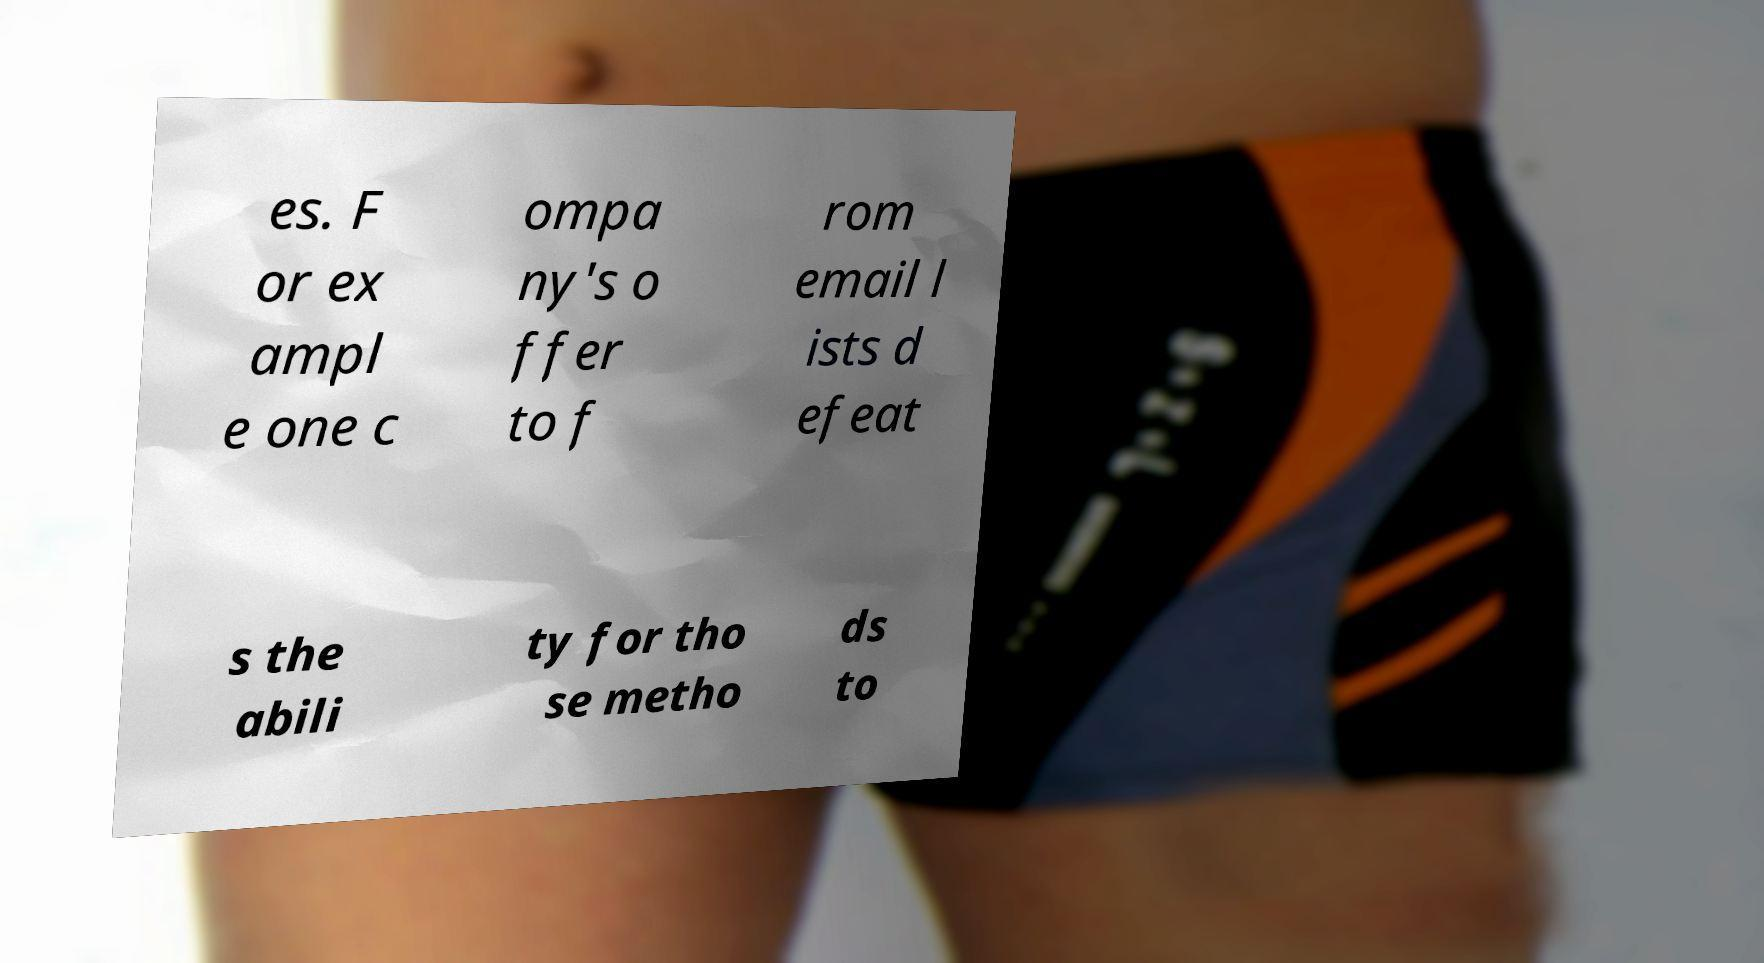For documentation purposes, I need the text within this image transcribed. Could you provide that? es. F or ex ampl e one c ompa ny's o ffer to f rom email l ists d efeat s the abili ty for tho se metho ds to 